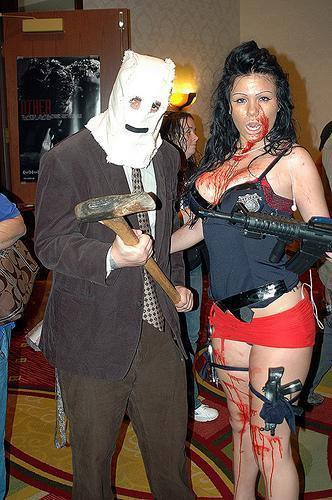How many people are wearing a mask?
Give a very brief answer. 1. 